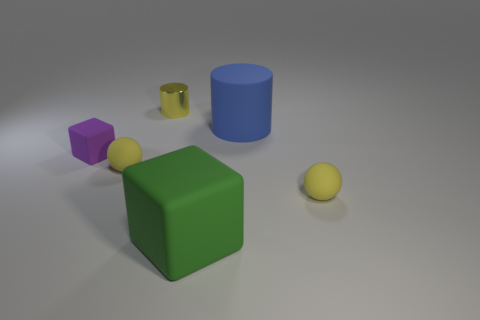Can you tell me about the lighting in the scene? The lighting in the scene suggests an indoor setting with a soft, diffuse overhead light source, which casts gentle shadows to the right of the objects. This type of lighting could be consistent with studio lighting used in photography or computer graphics to emphasize the form and color of the subjects without creating harsh shadows. 